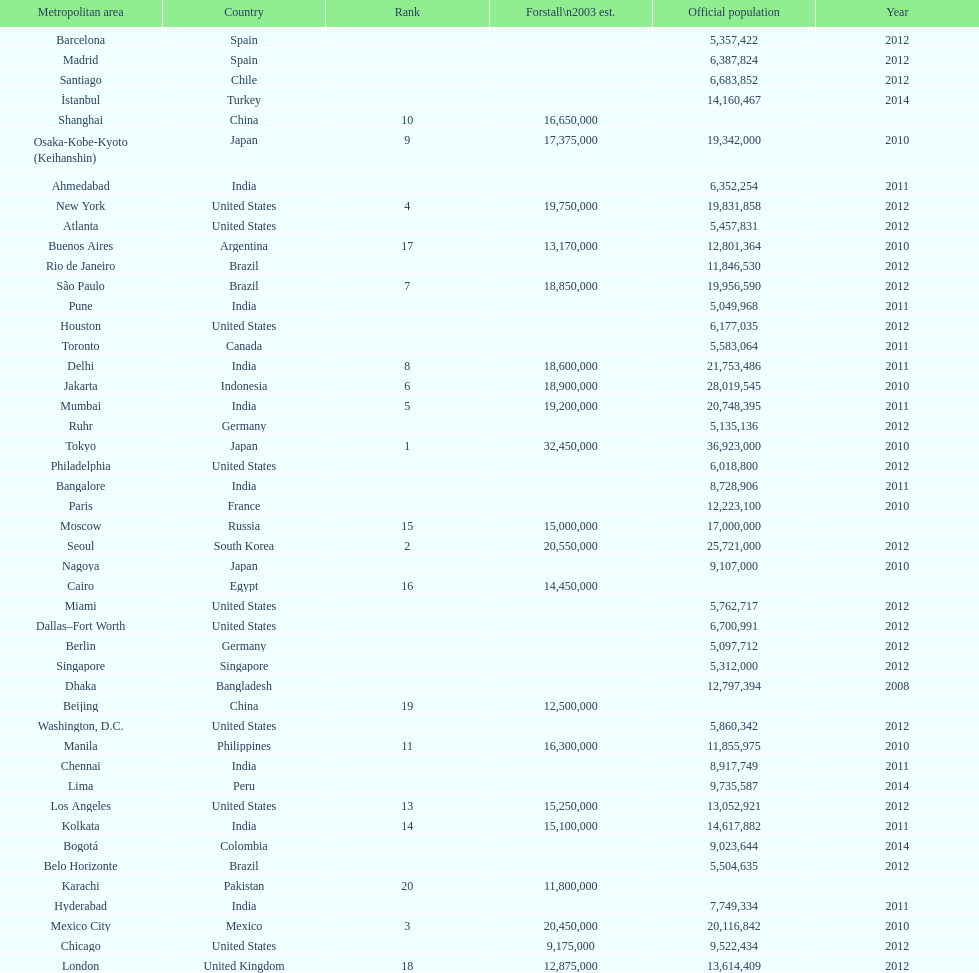Which region is mentioned above chicago? Chennai. 